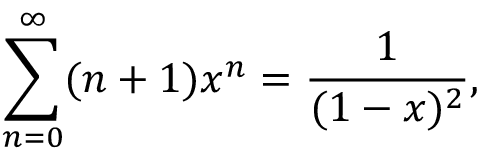<formula> <loc_0><loc_0><loc_500><loc_500>\sum _ { n = 0 } ^ { \infty } ( n + 1 ) x ^ { n } = { \frac { 1 } { ( 1 - x ) ^ { 2 } } } ,</formula> 